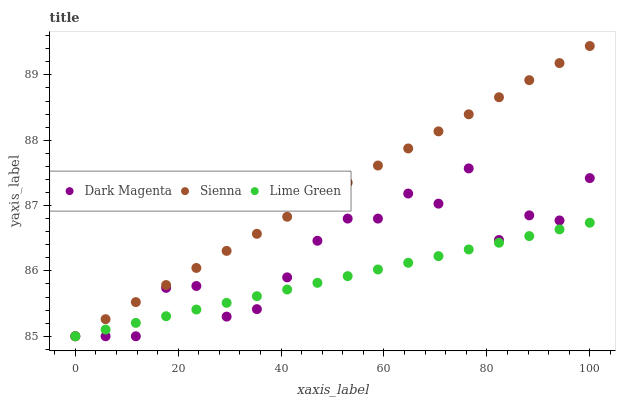Does Lime Green have the minimum area under the curve?
Answer yes or no. Yes. Does Sienna have the maximum area under the curve?
Answer yes or no. Yes. Does Dark Magenta have the minimum area under the curve?
Answer yes or no. No. Does Dark Magenta have the maximum area under the curve?
Answer yes or no. No. Is Lime Green the smoothest?
Answer yes or no. Yes. Is Dark Magenta the roughest?
Answer yes or no. Yes. Is Dark Magenta the smoothest?
Answer yes or no. No. Is Lime Green the roughest?
Answer yes or no. No. Does Sienna have the lowest value?
Answer yes or no. Yes. Does Sienna have the highest value?
Answer yes or no. Yes. Does Dark Magenta have the highest value?
Answer yes or no. No. Does Dark Magenta intersect Lime Green?
Answer yes or no. Yes. Is Dark Magenta less than Lime Green?
Answer yes or no. No. Is Dark Magenta greater than Lime Green?
Answer yes or no. No. 